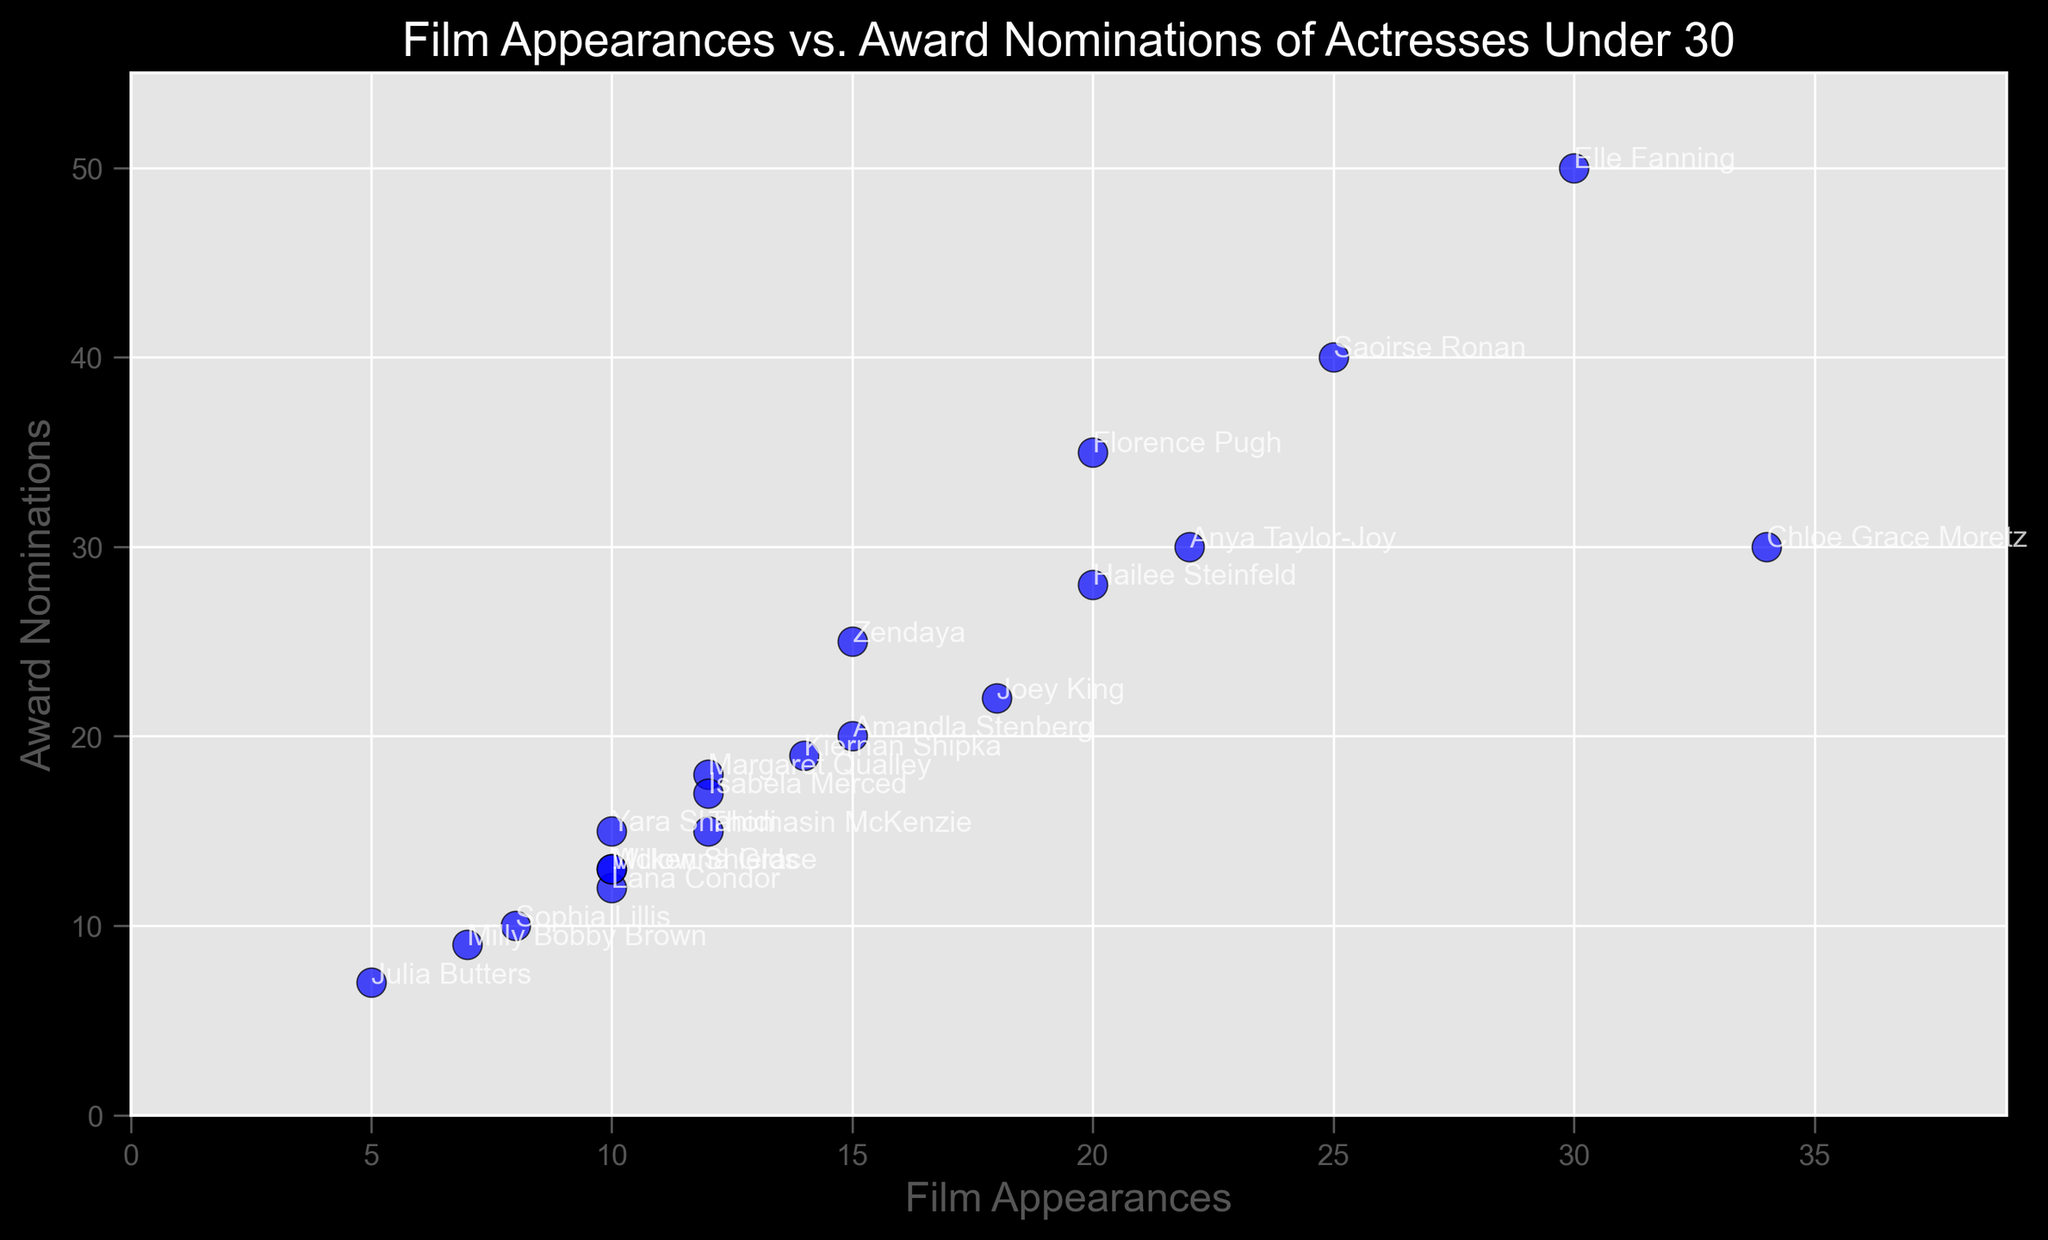What is the range in the number of film appearances among the actresses shown? The actress with the highest number of film appearances is Chloe Grace Moretz with 34, and the actress with the lowest is Julia Butters with 5. The range is calculated by subtracting the minimum from the maximum: 34 - 5 = 29
Answer: 29 Which actress has the highest number of award nominations, and how many nominations does she have? By looking at the scatter plot, Elle Fanning has the highest number of award nominations with a total of 50. Her data point is at the top of the y-axis among the others.
Answer: Elle Fanning, 50 Is there a positive correlation between film appearances and award nominations based on this scatter plot? By observing the scatter plot, a positive trend can be seen where actresses with more film appearances tend to have more award nominations, indicating a potential positive correlation.
Answer: Yes Who has more award nominations: Florence Pugh or Anya Taylor-Joy, and by how many? Florence Pugh has 35 award nominations, while Anya Taylor-Joy has 30. The difference is 35 - 30 = 5
Answer: Florence Pugh by 5 What is the combined total of film appearances for all actresses under 25 in the dataset? The actresses under 25 are Elle Fanning (30), Yara Shahidi (10), Joey King (18), Kiernan Shipka (14), Isabela Merced (12), Milly Bobby Brown (7), Sophia Lillis (8), Amandla Stenberg (15), Willow Shields (10), Thomasin McKenzie (12), Julia Butters (5), and Mckenna Grace (10). Adding these together: 30 + 10 + 18 + 14 + 12 + 7 + 8 + 15 + 10 + 12 + 5 + 10 = 151
Answer: 151 Which actresses have specifically 20 award nominations? By looking at the scatter plot annotations, the actresses with exactly 20 award nominations are Amandla Stenberg.
Answer: Amandla Stenberg Who has made the fewest film appearances, Milly Bobby Brown or Julia Butters? According to the scatter plot, Julia Butters has made 5 appearances, whereas Milly Bobby Brown has made 7. Julia Butters has made fewer film appearances.
Answer: Julia Butters What is the average number of award nominations for actresses aged 26? The actresses aged 26 are Zendaya (25 nominations), Chloe Grace Moretz (30), Hailee Steinfeld (28), and Lana Condor (12). The average is calculated by summing up the nominations and dividing by the number of actresses: (25 + 30 + 28 + 12) / 4 = 23.75
Answer: 23.75 Among the actresses with more than 10 film appearances, who has the lowest number of award nominations? From the scatter plot, among the actresses with more than 10 film appearances, the one with the lowest nominations is Isabela Merced with 17 nominations.
Answer: Isabela Merced How many actresses in the dataset have 10 film appearances or fewer? According to the scatter plot, the actresses with 10 film appearances or fewer are Yara Shahidi (10), Lana Condor (10), Milly Bobby Brown (7), Sophia Lillis (8), Julia Butters (5), and Mckenna Grace (10). There are 6 such actresses.
Answer: 6 